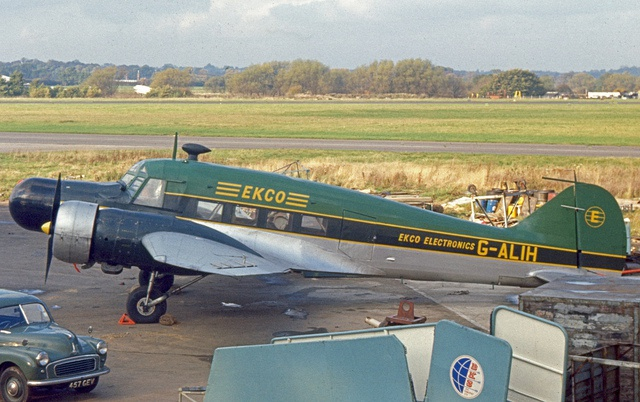Describe the objects in this image and their specific colors. I can see airplane in lightgray, teal, darkgray, and black tones and car in lightgray, gray, black, and darkgray tones in this image. 